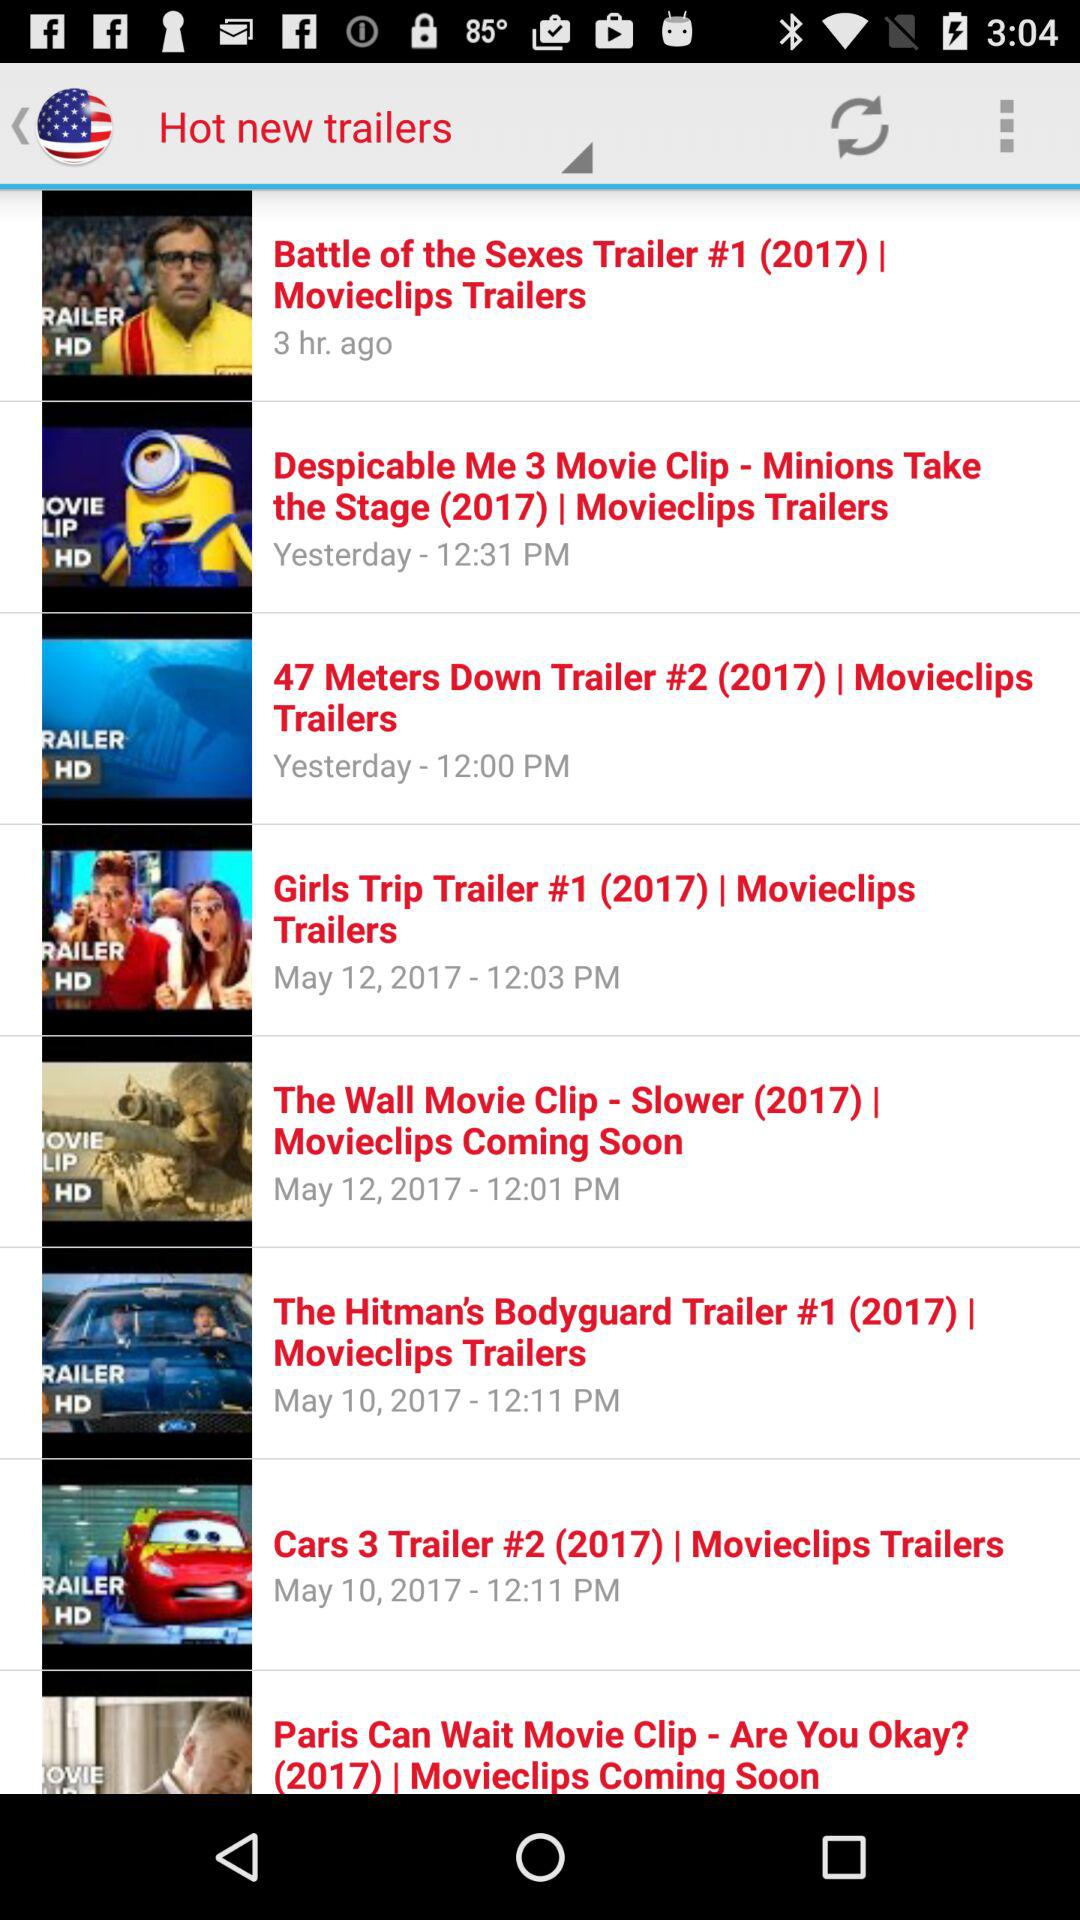What is the time for the trailer titled "The Wall Movie Clip - Slower (2017)"? The time for the trailer is 12:01 PM. 